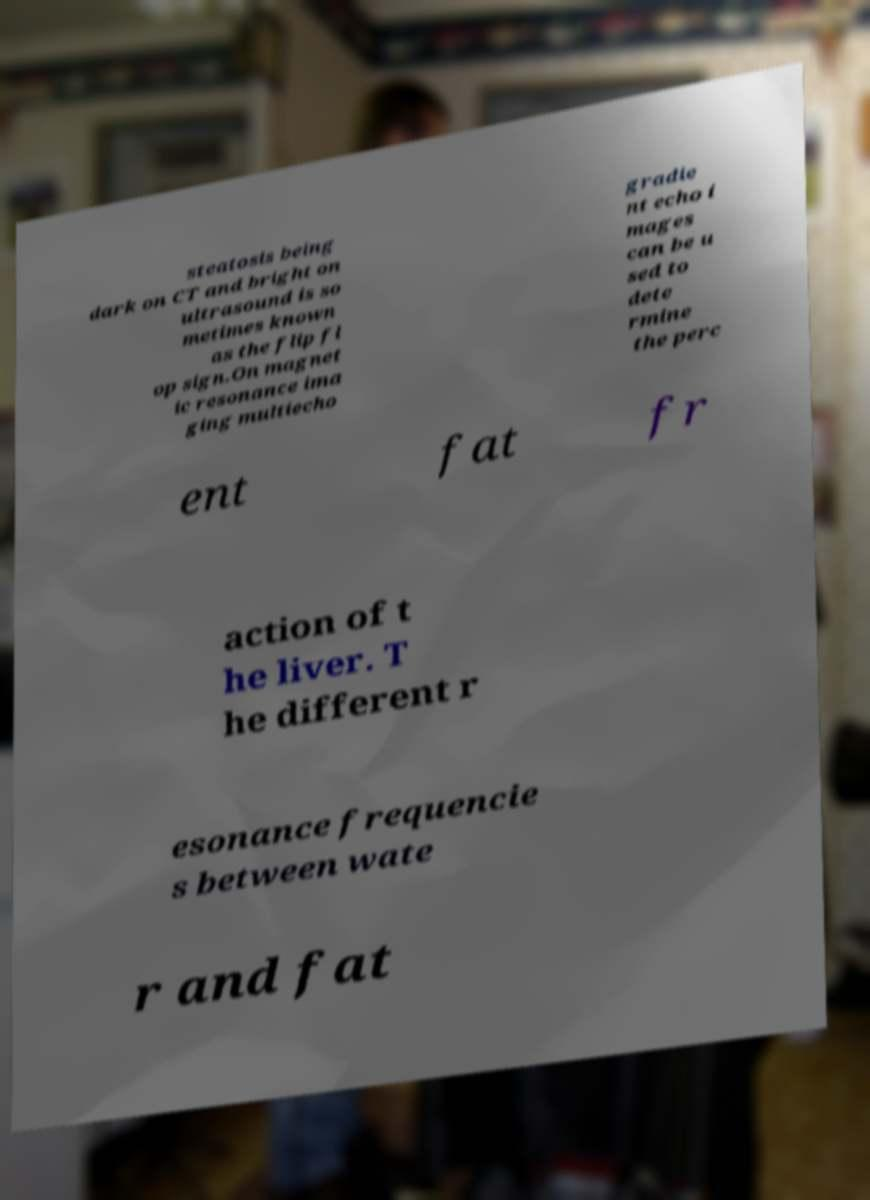I need the written content from this picture converted into text. Can you do that? steatosis being dark on CT and bright on ultrasound is so metimes known as the flip fl op sign.On magnet ic resonance ima ging multiecho gradie nt echo i mages can be u sed to dete rmine the perc ent fat fr action of t he liver. T he different r esonance frequencie s between wate r and fat 